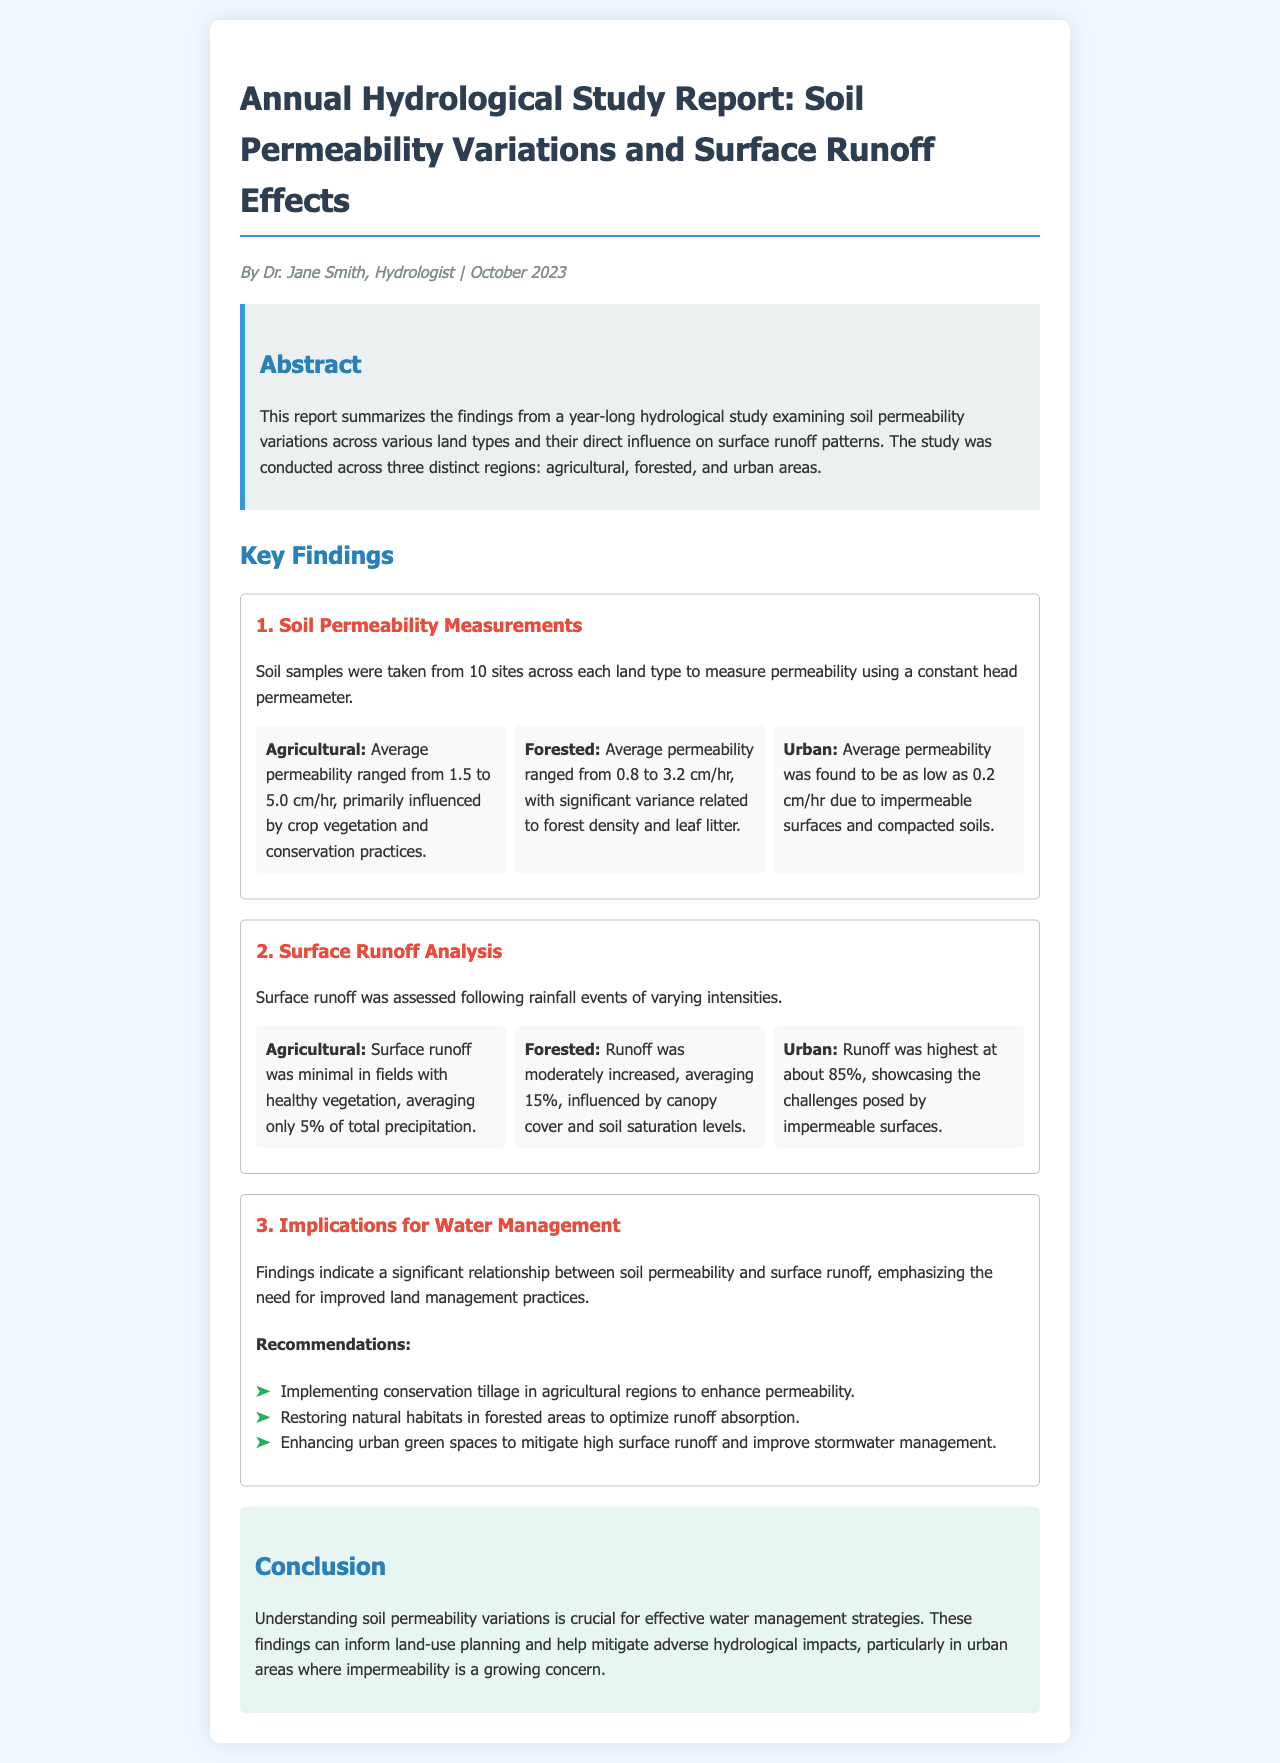What was the average permeability in agricultural areas? The average permeability in agricultural areas ranged from 1.5 to 5.0 cm/hr, influenced by crop vegetation and conservation practices.
Answer: 1.5 to 5.0 cm/hr What factor most influenced permeability in forested areas? The significant variance in permeability in forested areas is related to forest density and leaf litter.
Answer: Forest density and leaf litter What percentage of total precipitation was surface runoff in urban areas? Surface runoff in urban areas was the highest, averaging about 85%, showcasing challenges posed by impermeable surfaces.
Answer: 85% What was the purpose of the hydrological study? The study aimed to examine soil permeability variations across various land types and their direct influence on surface runoff patterns.
Answer: To examine soil permeability variations How many sites were sampled for soil permeability measurements? Soil samples were taken from 10 sites across each land type for the measurements.
Answer: 10 sites What management practice is recommended for agricultural regions? Implementing conservation tillage is advised to enhance permeability in agricultural regions.
Answer: Conservation tillage Which area showed the lowest average soil permeability? The urban area showed the lowest average permeability due to impermeable surfaces and compacted soils.
Answer: Urban What is crucial for effective water management strategies? Understanding soil permeability variations is crucial for developing effective water management strategies.
Answer: Understanding soil permeability variations 